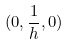Convert formula to latex. <formula><loc_0><loc_0><loc_500><loc_500>( 0 , \frac { 1 } { h } , 0 )</formula> 